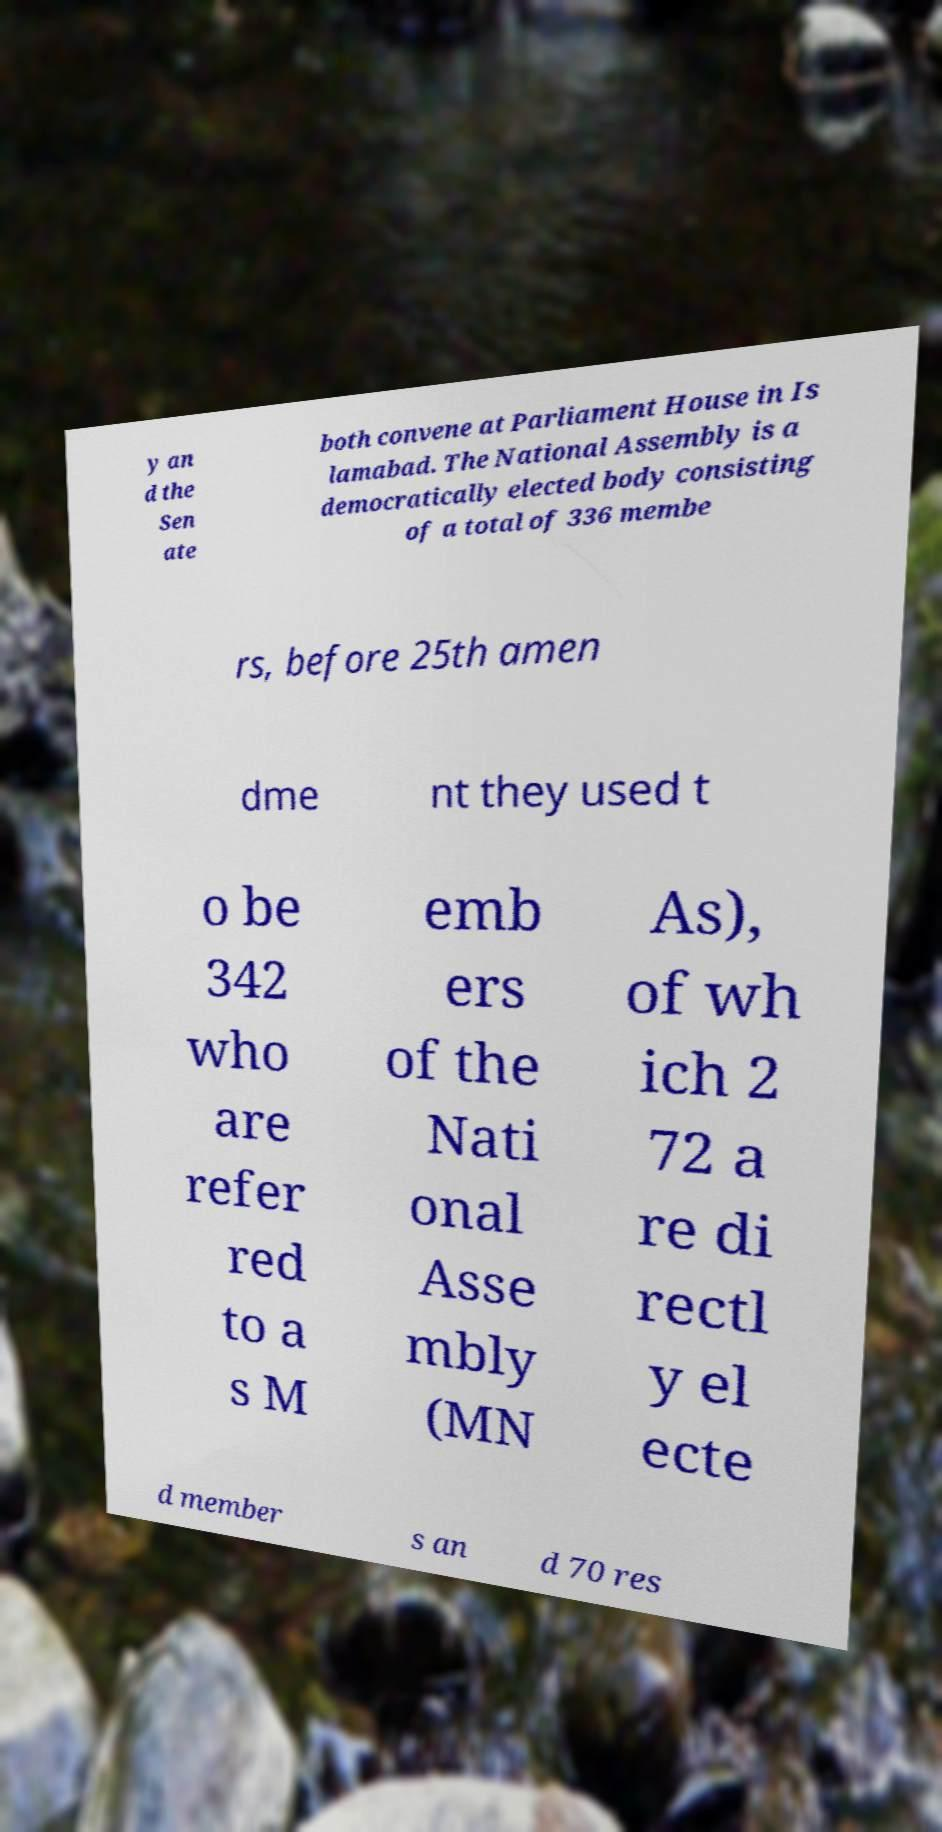Could you extract and type out the text from this image? y an d the Sen ate both convene at Parliament House in Is lamabad. The National Assembly is a democratically elected body consisting of a total of 336 membe rs, before 25th amen dme nt they used t o be 342 who are refer red to a s M emb ers of the Nati onal Asse mbly (MN As), of wh ich 2 72 a re di rectl y el ecte d member s an d 70 res 